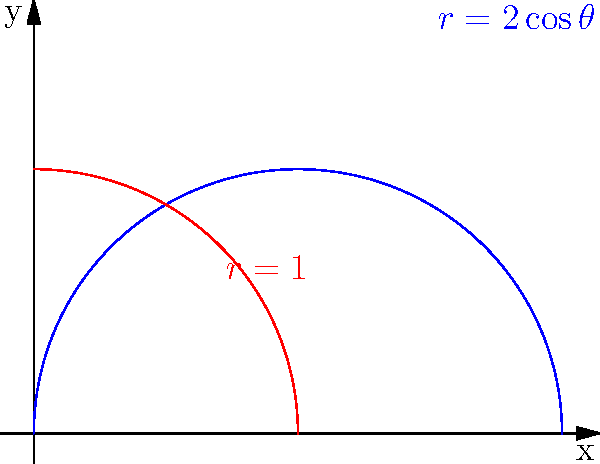Consider the polar curves $r = 2\cos\theta$ and $r = 1$, as shown in the figure. Calculate the area of the region bounded by these two curves in the first quadrant. To find the area between two polar curves, we can use the formula:

$$A = \frac{1}{2} \int_{\alpha}^{\beta} (r_2^2 - r_1^2) d\theta$$

Where $r_2$ is the outer curve and $r_1$ is the inner curve.

Step 1: Determine the limits of integration.
The curves intersect when $2\cos\theta = 1$, which occurs at $\theta = \pm \frac{\pi}{3}$. In the first quadrant, we integrate from 0 to $\frac{\pi}{3}$.

Step 2: Set up the integral.
$$A = \frac{1}{2} \int_{0}^{\pi/3} ((2\cos\theta)^2 - 1^2) d\theta$$

Step 3: Simplify the integrand.
$$A = \frac{1}{2} \int_{0}^{\pi/3} (4\cos^2\theta - 1) d\theta$$

Step 4: Use the identity $\cos^2\theta = \frac{1 + \cos(2\theta)}{2}$.
$$A = \frac{1}{2} \int_{0}^{\pi/3} (4(\frac{1 + \cos(2\theta)}{2}) - 1) d\theta$$
$$A = \frac{1}{2} \int_{0}^{\pi/3} (2 + 2\cos(2\theta) - 1) d\theta$$
$$A = \frac{1}{2} \int_{0}^{\pi/3} (1 + 2\cos(2\theta)) d\theta$$

Step 5: Integrate.
$$A = \frac{1}{2} [\theta + \sin(2\theta)]_{0}^{\pi/3}$$

Step 6: Evaluate the integral.
$$A = \frac{1}{2} [(\frac{\pi}{3} + \sin(\frac{2\pi}{3})) - (0 + \sin(0))]$$
$$A = \frac{1}{2} [\frac{\pi}{3} + \frac{\sqrt{3}}{2}]$$

Step 7: Simplify the final answer.
$$A = \frac{\pi}{6} + \frac{\sqrt{3}}{4}$$
Answer: $\frac{\pi}{6} + \frac{\sqrt{3}}{4}$ 